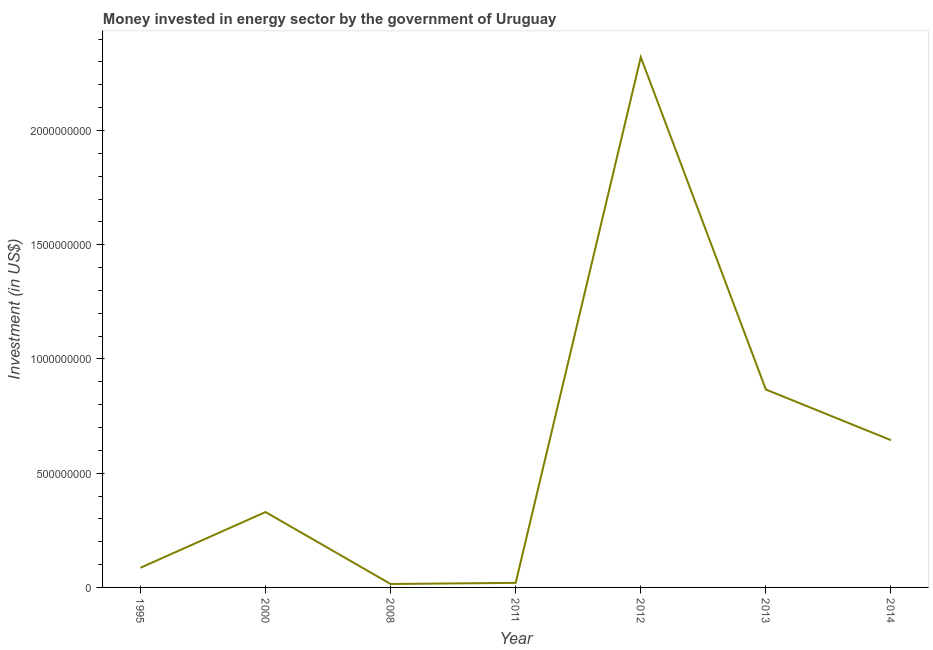What is the investment in energy in 2011?
Keep it short and to the point. 2.00e+07. Across all years, what is the maximum investment in energy?
Offer a terse response. 2.32e+09. Across all years, what is the minimum investment in energy?
Your answer should be compact. 1.50e+07. In which year was the investment in energy minimum?
Provide a short and direct response. 2008. What is the sum of the investment in energy?
Ensure brevity in your answer.  4.28e+09. What is the difference between the investment in energy in 1995 and 2012?
Provide a succinct answer. -2.24e+09. What is the average investment in energy per year?
Ensure brevity in your answer.  6.12e+08. What is the median investment in energy?
Offer a terse response. 3.30e+08. Is the investment in energy in 2000 less than that in 2013?
Keep it short and to the point. Yes. What is the difference between the highest and the second highest investment in energy?
Your response must be concise. 1.45e+09. What is the difference between the highest and the lowest investment in energy?
Your answer should be very brief. 2.31e+09. Are the values on the major ticks of Y-axis written in scientific E-notation?
Provide a short and direct response. No. Does the graph contain grids?
Provide a short and direct response. No. What is the title of the graph?
Offer a terse response. Money invested in energy sector by the government of Uruguay. What is the label or title of the Y-axis?
Your response must be concise. Investment (in US$). What is the Investment (in US$) of 1995?
Provide a short and direct response. 8.60e+07. What is the Investment (in US$) in 2000?
Provide a short and direct response. 3.30e+08. What is the Investment (in US$) of 2008?
Your answer should be very brief. 1.50e+07. What is the Investment (in US$) of 2012?
Your answer should be compact. 2.32e+09. What is the Investment (in US$) in 2013?
Your answer should be compact. 8.66e+08. What is the Investment (in US$) of 2014?
Give a very brief answer. 6.44e+08. What is the difference between the Investment (in US$) in 1995 and 2000?
Ensure brevity in your answer.  -2.44e+08. What is the difference between the Investment (in US$) in 1995 and 2008?
Offer a very short reply. 7.10e+07. What is the difference between the Investment (in US$) in 1995 and 2011?
Make the answer very short. 6.60e+07. What is the difference between the Investment (in US$) in 1995 and 2012?
Provide a succinct answer. -2.24e+09. What is the difference between the Investment (in US$) in 1995 and 2013?
Your answer should be very brief. -7.80e+08. What is the difference between the Investment (in US$) in 1995 and 2014?
Give a very brief answer. -5.58e+08. What is the difference between the Investment (in US$) in 2000 and 2008?
Your answer should be compact. 3.15e+08. What is the difference between the Investment (in US$) in 2000 and 2011?
Give a very brief answer. 3.10e+08. What is the difference between the Investment (in US$) in 2000 and 2012?
Your answer should be compact. -1.99e+09. What is the difference between the Investment (in US$) in 2000 and 2013?
Your answer should be very brief. -5.36e+08. What is the difference between the Investment (in US$) in 2000 and 2014?
Provide a succinct answer. -3.14e+08. What is the difference between the Investment (in US$) in 2008 and 2011?
Offer a very short reply. -5.00e+06. What is the difference between the Investment (in US$) in 2008 and 2012?
Give a very brief answer. -2.31e+09. What is the difference between the Investment (in US$) in 2008 and 2013?
Provide a succinct answer. -8.51e+08. What is the difference between the Investment (in US$) in 2008 and 2014?
Your answer should be very brief. -6.30e+08. What is the difference between the Investment (in US$) in 2011 and 2012?
Your answer should be compact. -2.30e+09. What is the difference between the Investment (in US$) in 2011 and 2013?
Offer a very short reply. -8.46e+08. What is the difference between the Investment (in US$) in 2011 and 2014?
Ensure brevity in your answer.  -6.24e+08. What is the difference between the Investment (in US$) in 2012 and 2013?
Provide a short and direct response. 1.45e+09. What is the difference between the Investment (in US$) in 2012 and 2014?
Your answer should be compact. 1.68e+09. What is the difference between the Investment (in US$) in 2013 and 2014?
Your answer should be very brief. 2.22e+08. What is the ratio of the Investment (in US$) in 1995 to that in 2000?
Keep it short and to the point. 0.26. What is the ratio of the Investment (in US$) in 1995 to that in 2008?
Your answer should be compact. 5.73. What is the ratio of the Investment (in US$) in 1995 to that in 2012?
Provide a short and direct response. 0.04. What is the ratio of the Investment (in US$) in 1995 to that in 2013?
Give a very brief answer. 0.1. What is the ratio of the Investment (in US$) in 1995 to that in 2014?
Offer a very short reply. 0.13. What is the ratio of the Investment (in US$) in 2000 to that in 2008?
Your answer should be compact. 22. What is the ratio of the Investment (in US$) in 2000 to that in 2012?
Ensure brevity in your answer.  0.14. What is the ratio of the Investment (in US$) in 2000 to that in 2013?
Make the answer very short. 0.38. What is the ratio of the Investment (in US$) in 2000 to that in 2014?
Provide a succinct answer. 0.51. What is the ratio of the Investment (in US$) in 2008 to that in 2012?
Your answer should be very brief. 0.01. What is the ratio of the Investment (in US$) in 2008 to that in 2013?
Provide a short and direct response. 0.02. What is the ratio of the Investment (in US$) in 2008 to that in 2014?
Make the answer very short. 0.02. What is the ratio of the Investment (in US$) in 2011 to that in 2012?
Give a very brief answer. 0.01. What is the ratio of the Investment (in US$) in 2011 to that in 2013?
Offer a terse response. 0.02. What is the ratio of the Investment (in US$) in 2011 to that in 2014?
Offer a terse response. 0.03. What is the ratio of the Investment (in US$) in 2012 to that in 2013?
Make the answer very short. 2.68. What is the ratio of the Investment (in US$) in 2012 to that in 2014?
Ensure brevity in your answer.  3.6. What is the ratio of the Investment (in US$) in 2013 to that in 2014?
Keep it short and to the point. 1.34. 